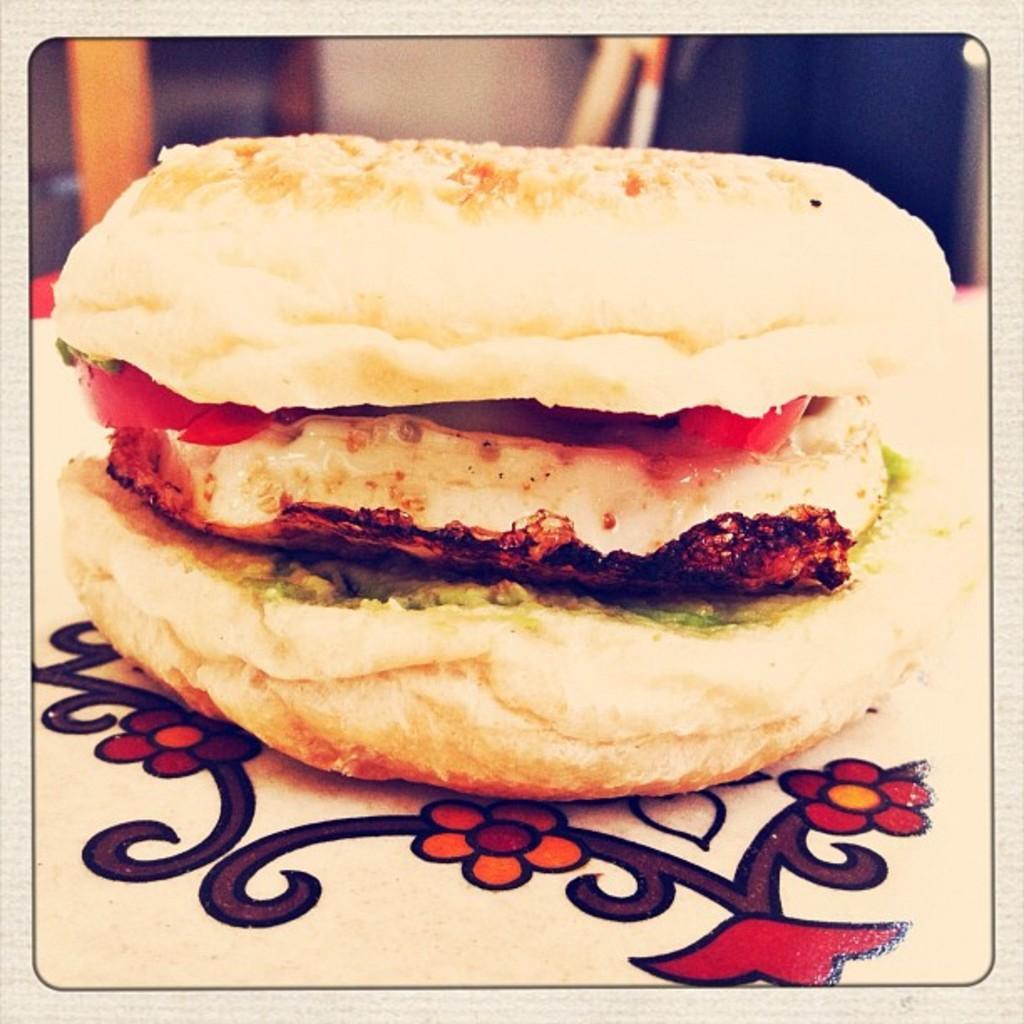Describe this image in one or two sentences. In this picture there is a burger on the table. In the background we can see the window near to the wall. 